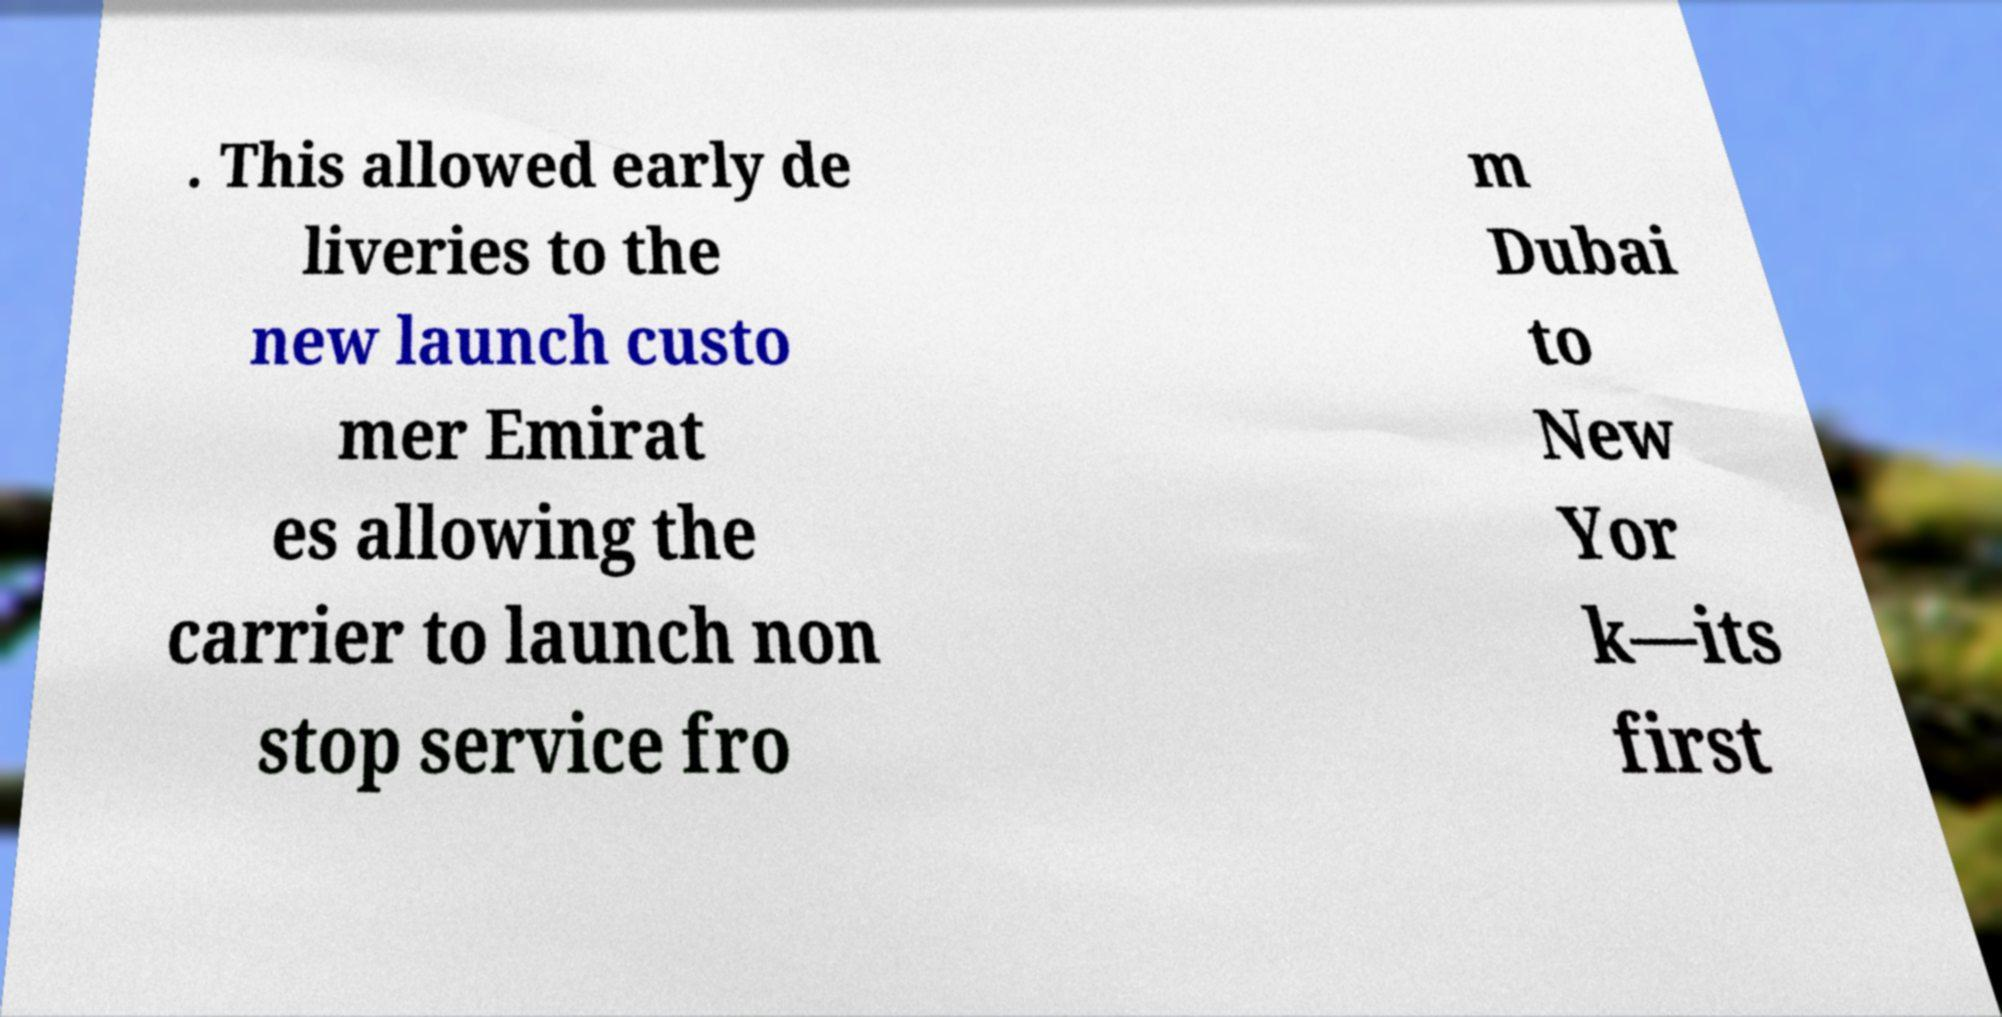Can you read and provide the text displayed in the image?This photo seems to have some interesting text. Can you extract and type it out for me? . This allowed early de liveries to the new launch custo mer Emirat es allowing the carrier to launch non stop service fro m Dubai to New Yor k—its first 